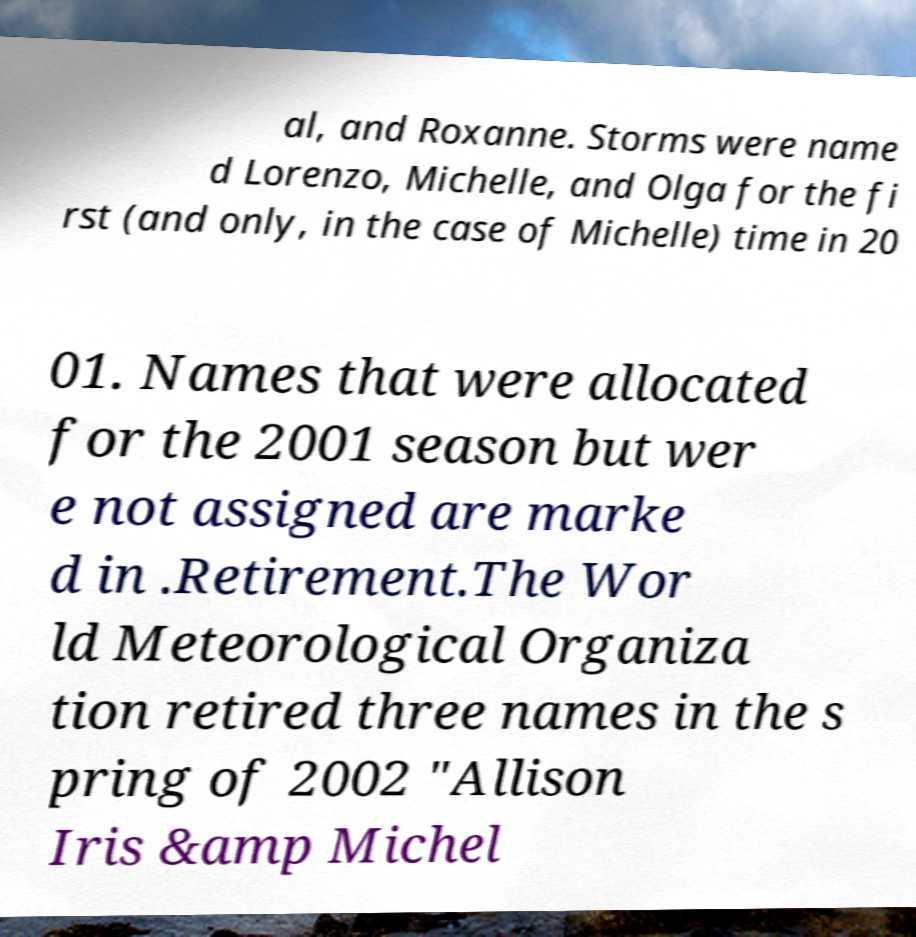Please identify and transcribe the text found in this image. al, and Roxanne. Storms were name d Lorenzo, Michelle, and Olga for the fi rst (and only, in the case of Michelle) time in 20 01. Names that were allocated for the 2001 season but wer e not assigned are marke d in .Retirement.The Wor ld Meteorological Organiza tion retired three names in the s pring of 2002 "Allison Iris &amp Michel 